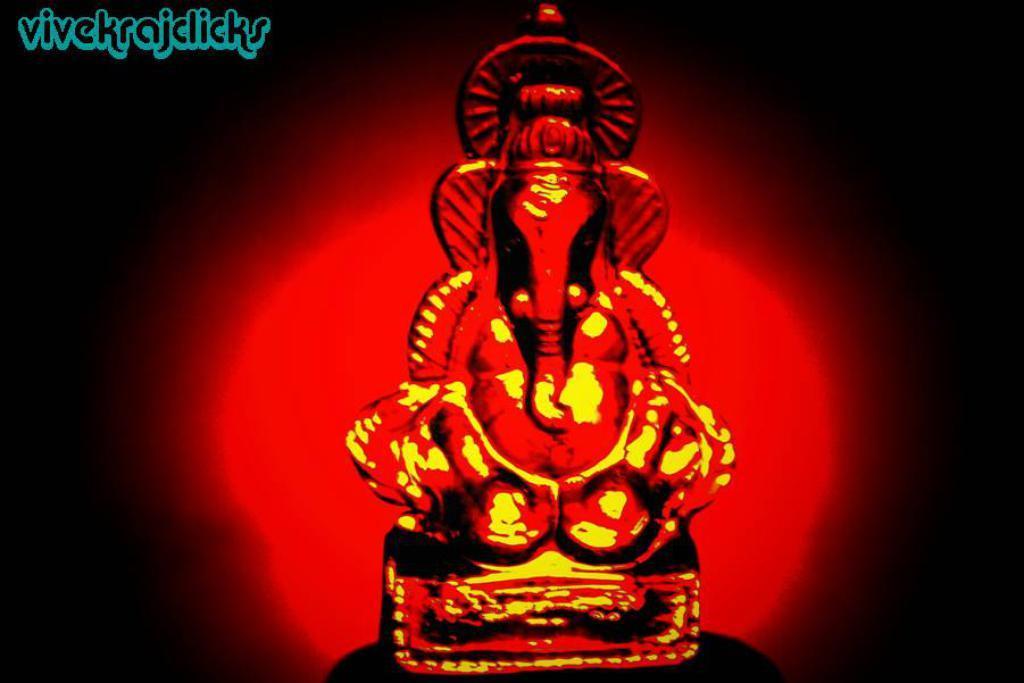Can you describe this image briefly? This picture shows a red color ganesha and we see text on the top left corner. 